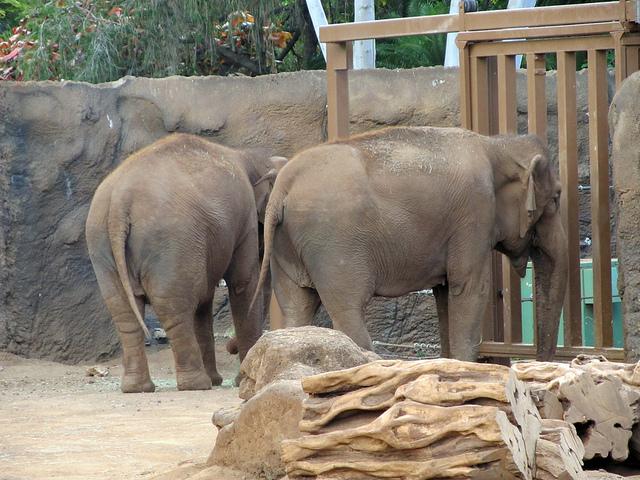Are the animals locked?
Quick response, please. Yes. What are the animals?
Short answer required. Elephants. What is the brown cow leaning on?
Concise answer only. Fence. How many elephants can you see?
Answer briefly. 2. Is this located at a zoo?
Give a very brief answer. Yes. 